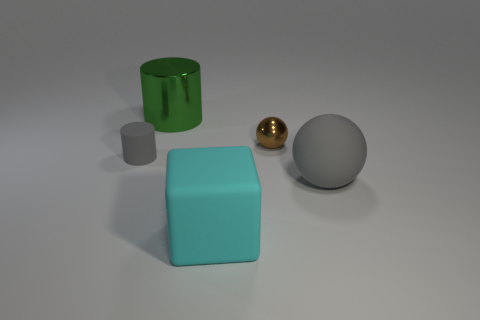Add 4 brown shiny spheres. How many objects exist? 9 Subtract all balls. How many objects are left? 3 Subtract all gray cylinders. How many cylinders are left? 1 Add 1 small metal balls. How many small metal balls exist? 2 Subtract 0 yellow blocks. How many objects are left? 5 Subtract 1 cylinders. How many cylinders are left? 1 Subtract all green cylinders. Subtract all brown cubes. How many cylinders are left? 1 Subtract all green cubes. How many red balls are left? 0 Subtract all small yellow matte objects. Subtract all large gray things. How many objects are left? 4 Add 5 small gray cylinders. How many small gray cylinders are left? 6 